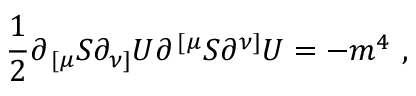Convert formula to latex. <formula><loc_0><loc_0><loc_500><loc_500>{ \frac { 1 } { 2 } } \partial _ { \, [ \mu } S \partial _ { \nu ] } U \partial ^ { \, [ \mu } S \partial ^ { \nu ] } U = - m ^ { 4 } \ ,</formula> 